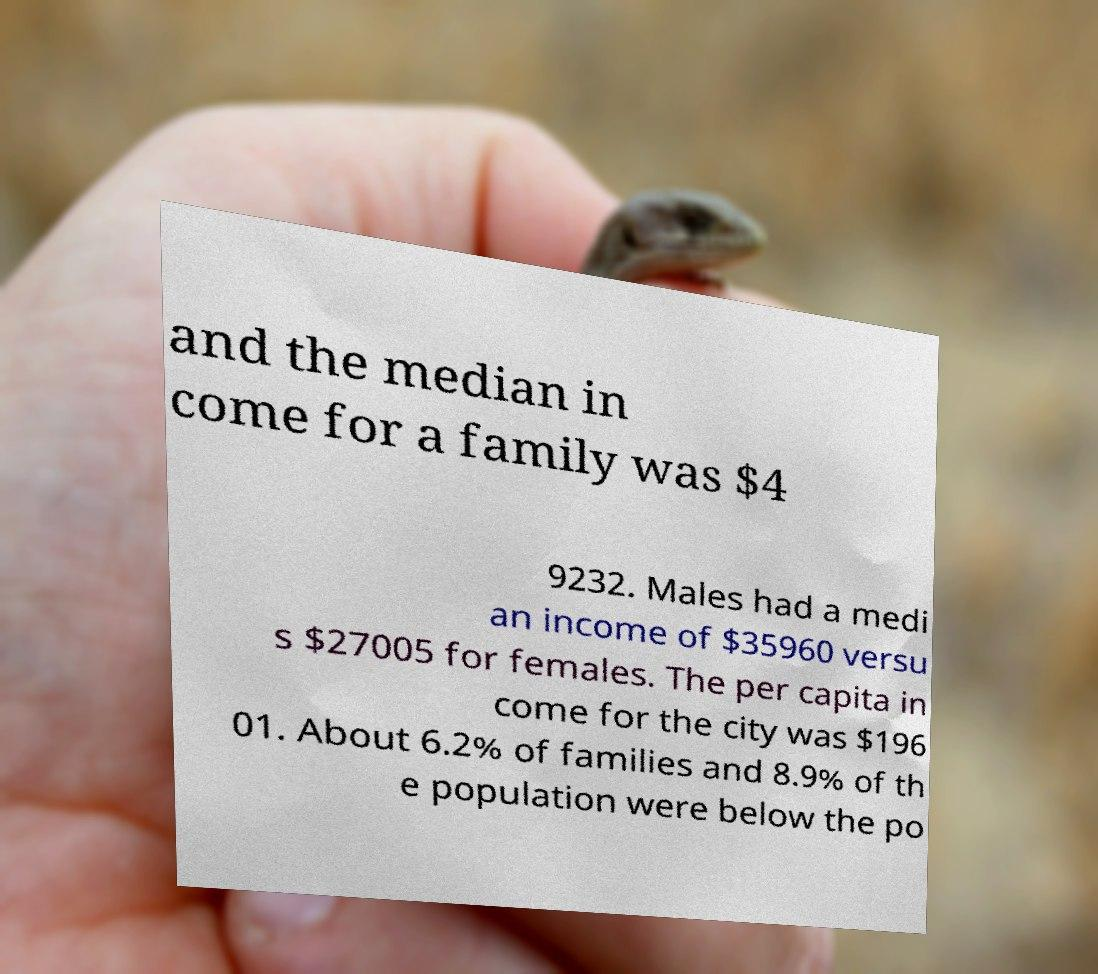I need the written content from this picture converted into text. Can you do that? and the median in come for a family was $4 9232. Males had a medi an income of $35960 versu s $27005 for females. The per capita in come for the city was $196 01. About 6.2% of families and 8.9% of th e population were below the po 